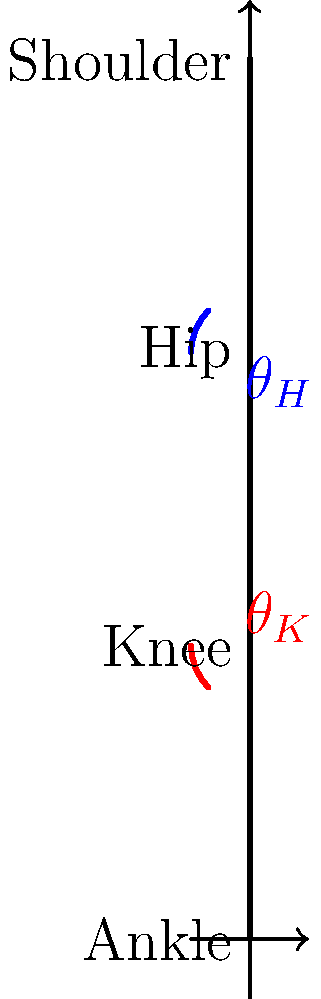In a data-driven biomechanical analysis of a squat exercise, you're examining joint angles. The stick figure diagram shows a person at the bottom of a squat. Given that the knee angle ($\theta_K$) is 45° and the hip angle ($\theta_H$) is 90°, what is the total range of motion (ROM) achieved by these two joints combined during the squat, assuming the starting position was standing upright? To solve this problem, we need to follow these steps:

1. Understand the starting position:
   - In the upright standing position, both knee and hip angles are typically 180°.

2. Calculate the ROM for the knee joint:
   - Starting angle: 180°
   - Ending angle (from diagram): $\theta_K = 45°$
   - Knee ROM = 180° - 45° = 135°

3. Calculate the ROM for the hip joint:
   - Starting angle: 180°
   - Ending angle (from diagram): $\theta_H = 90°$
   - Hip ROM = 180° - 90° = 90°

4. Sum the ROMs:
   - Total ROM = Knee ROM + Hip ROM
   - Total ROM = 135° + 90° = 225°

This problem demonstrates the importance of structured data analysis in biomechanics, where we break down complex movements into individual joint angles and combine them to understand the overall motion.
Answer: 225° 